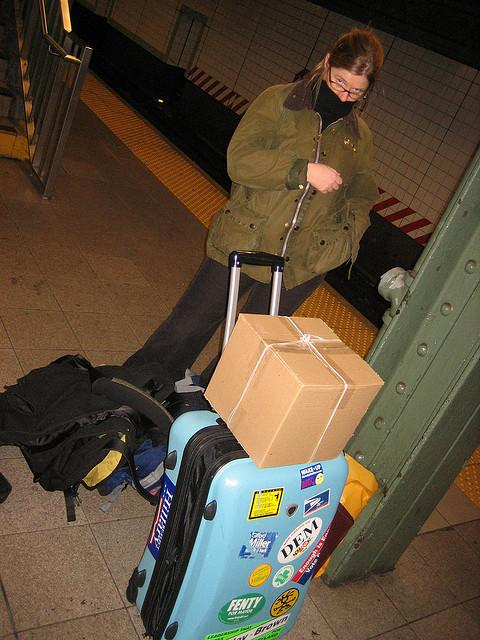What type of area is the woman waiting in? Please explain your reasoning. subway. The woman is at a subway track. 